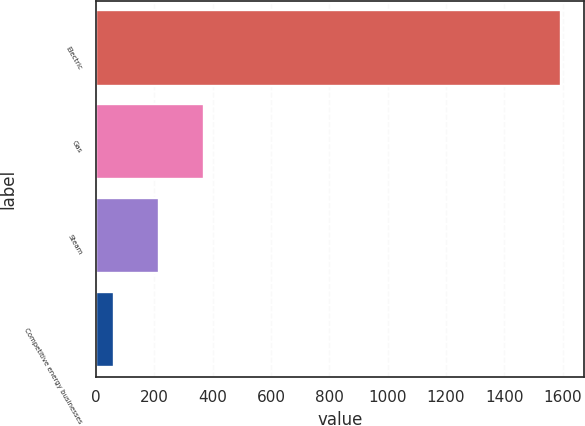<chart> <loc_0><loc_0><loc_500><loc_500><bar_chart><fcel>Electric<fcel>Gas<fcel>Steam<fcel>Competitive energy businesses<nl><fcel>1595<fcel>369.4<fcel>216.2<fcel>63<nl></chart> 